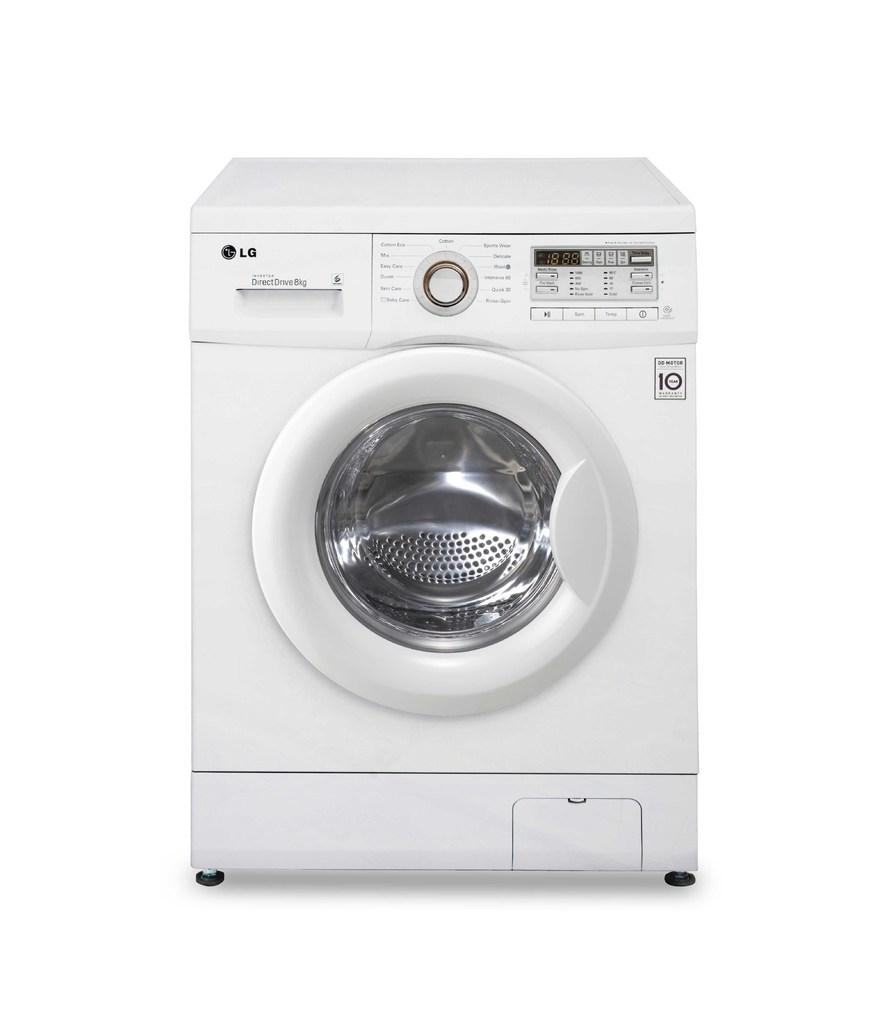What appliance is present in the image? There is a washing machine in the image. What else can be seen in the image besides the washing machine? There is text written in the image. What color is the background of the image? The background of the image is white. What type of offer is the uncle making in the image? There is no uncle or offer present in the image; it only features a washing machine and text on a white background. 